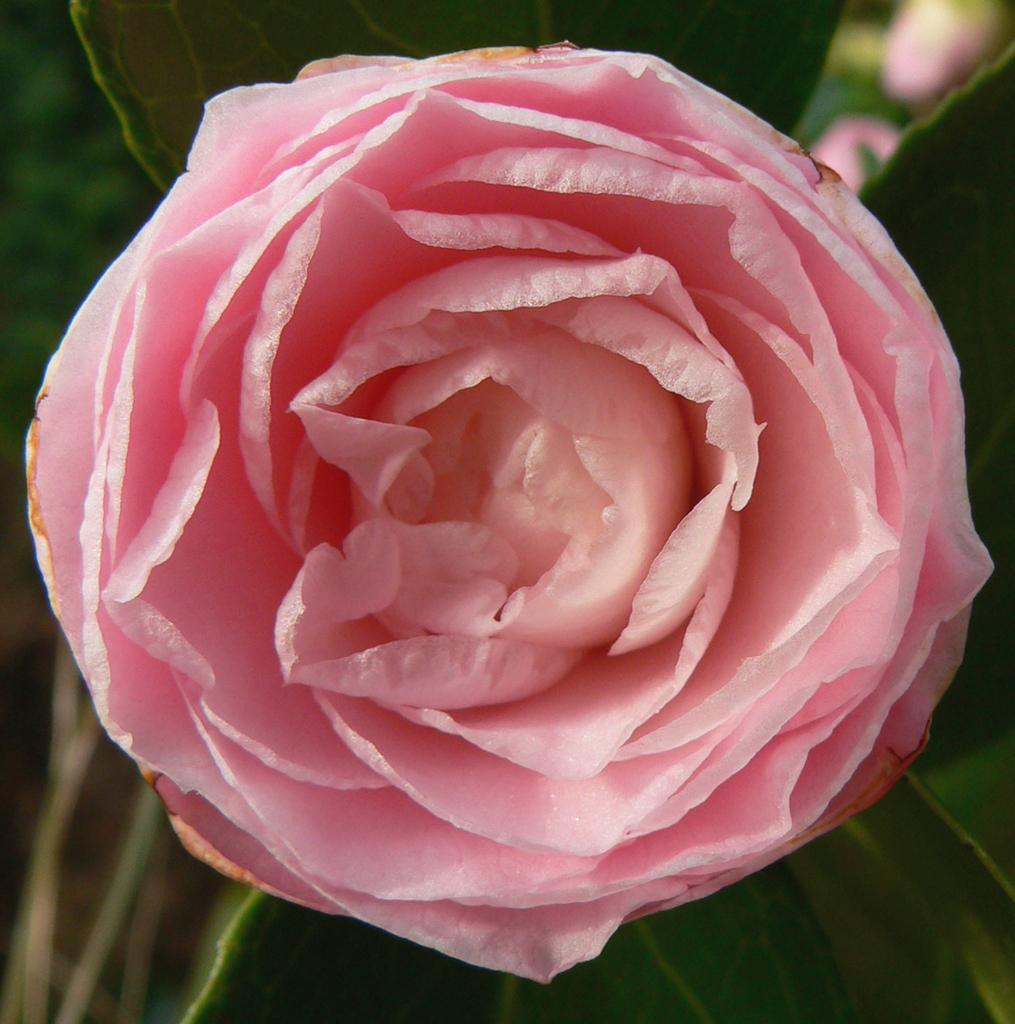What is the main subject of the image? There is a rose in the center of the image. What can be seen in the background of the image? There are leaves in the background of the image. What type of goat can be seen grazing on the rose in the image? There is no goat present in the image, and the rose is not being grazed upon. What design is featured on the petals of the rose in the image? The facts provided do not mention any specific design on the petals of the rose. 